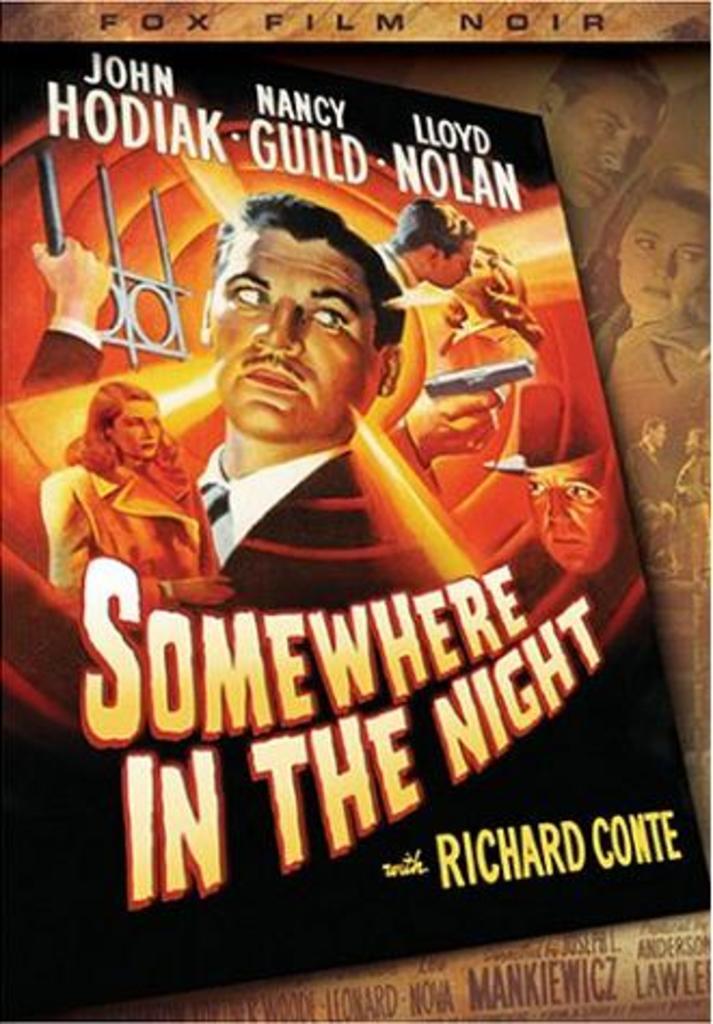What is the name of this movie?
Ensure brevity in your answer.  Somewhere in the night. What's the name printed on the top left?
Make the answer very short. John hodiak. 